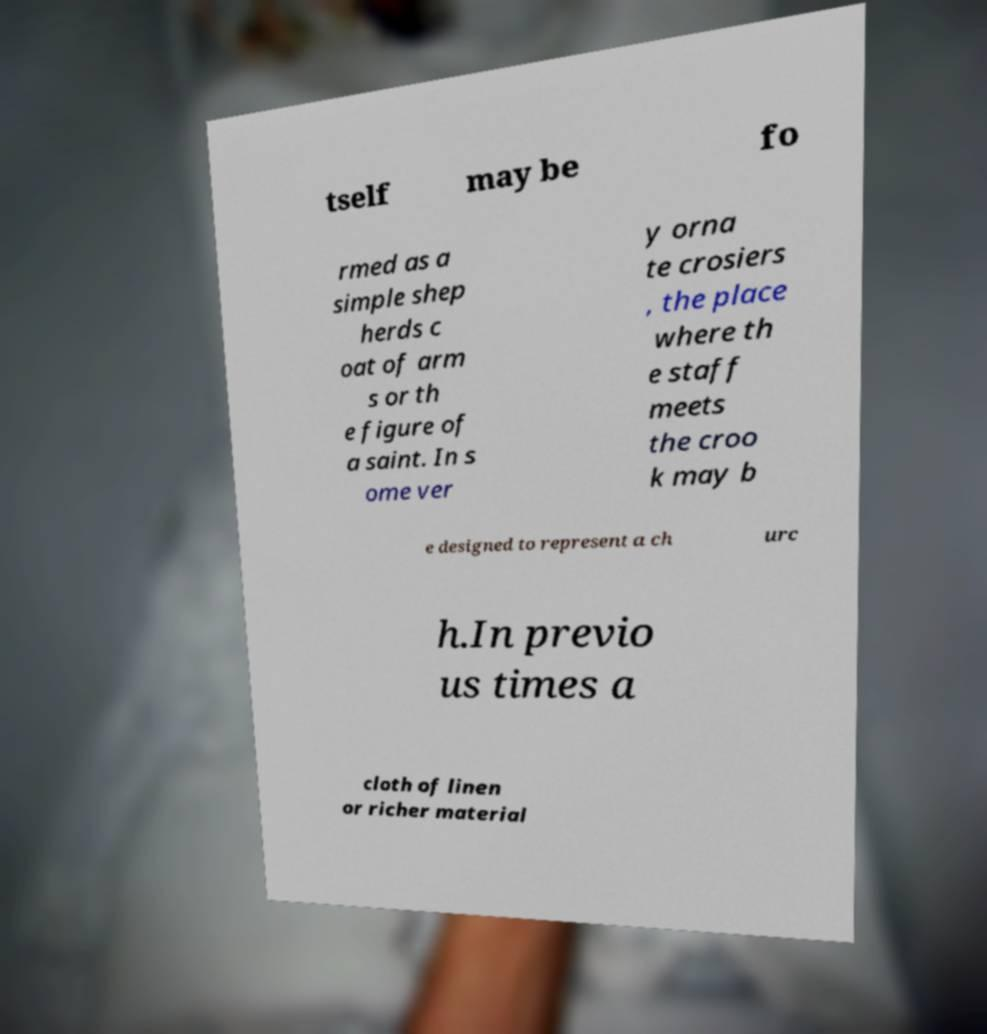Could you assist in decoding the text presented in this image and type it out clearly? tself may be fo rmed as a simple shep herds c oat of arm s or th e figure of a saint. In s ome ver y orna te crosiers , the place where th e staff meets the croo k may b e designed to represent a ch urc h.In previo us times a cloth of linen or richer material 